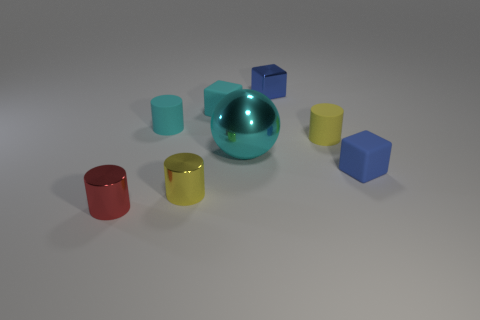Can you infer anything about the light source in this image? The shadows cast by the objects indicate a single light source located above and to the left of the scene. The light appears to be diffused, resulting in soft-edged shadows, which suggest an indoor setting with ambient lighting. 